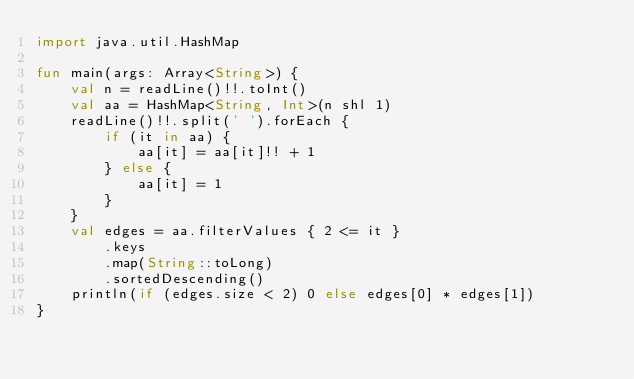Convert code to text. <code><loc_0><loc_0><loc_500><loc_500><_Kotlin_>import java.util.HashMap

fun main(args: Array<String>) {
    val n = readLine()!!.toInt()
    val aa = HashMap<String, Int>(n shl 1)
    readLine()!!.split(' ').forEach {
        if (it in aa) {
            aa[it] = aa[it]!! + 1
        } else {
            aa[it] = 1
        }
    }
    val edges = aa.filterValues { 2 <= it }
        .keys
        .map(String::toLong)
        .sortedDescending()
    println(if (edges.size < 2) 0 else edges[0] * edges[1])
}
</code> 